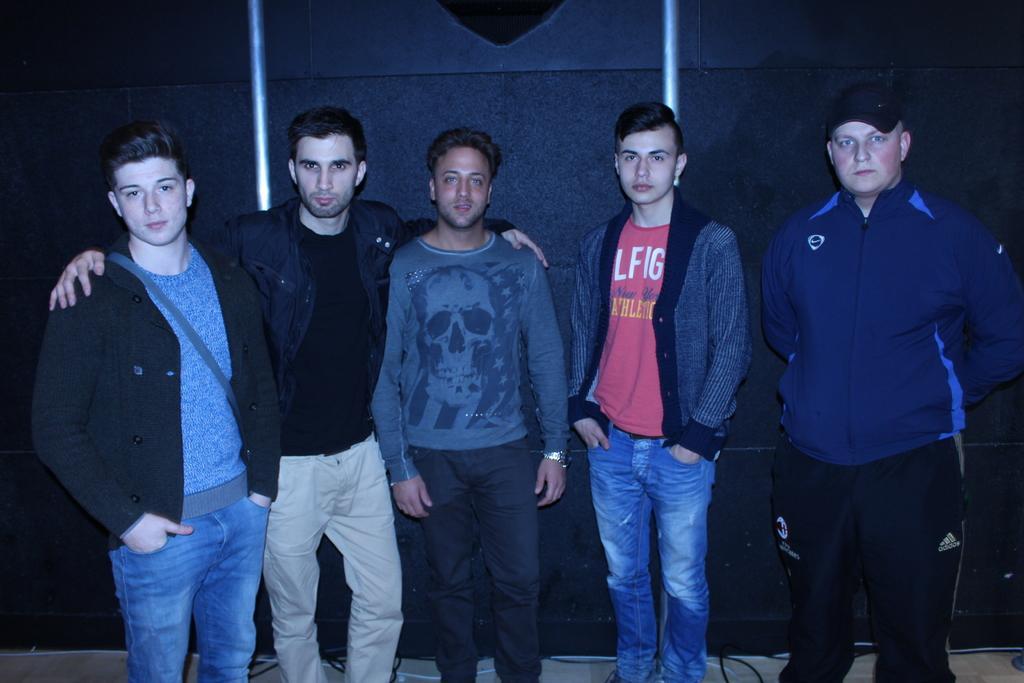In one or two sentences, can you explain what this image depicts? In this picture there are 5 men standing and looking at someone. 